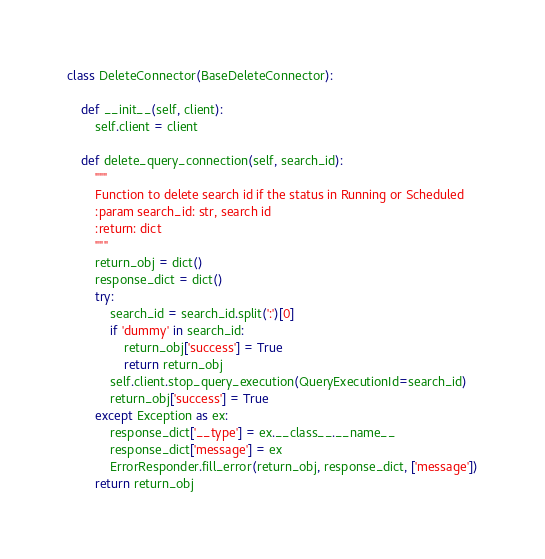<code> <loc_0><loc_0><loc_500><loc_500><_Python_>class DeleteConnector(BaseDeleteConnector):

    def __init__(self, client):
        self.client = client

    def delete_query_connection(self, search_id):
        """
        Function to delete search id if the status in Running or Scheduled
        :param search_id: str, search id
        :return: dict
        """
        return_obj = dict()
        response_dict = dict()
        try:
            search_id = search_id.split(':')[0]
            if 'dummy' in search_id:
                return_obj['success'] = True
                return return_obj
            self.client.stop_query_execution(QueryExecutionId=search_id)
            return_obj['success'] = True
        except Exception as ex:
            response_dict['__type'] = ex.__class__.__name__
            response_dict['message'] = ex
            ErrorResponder.fill_error(return_obj, response_dict, ['message'])
        return return_obj
</code> 